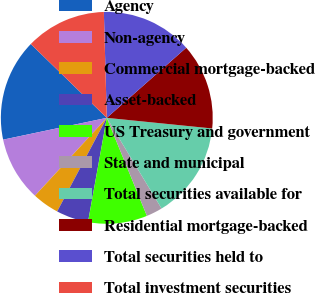<chart> <loc_0><loc_0><loc_500><loc_500><pie_chart><fcel>Agency<fcel>Non-agency<fcel>Commercial mortgage-backed<fcel>Asset-backed<fcel>US Treasury and government<fcel>State and municipal<fcel>Total securities available for<fcel>Residential mortgage-backed<fcel>Total securities held to<fcel>Total investment securities<nl><fcel>15.57%<fcel>9.84%<fcel>4.1%<fcel>4.92%<fcel>9.02%<fcel>2.47%<fcel>14.75%<fcel>13.11%<fcel>13.93%<fcel>12.29%<nl></chart> 